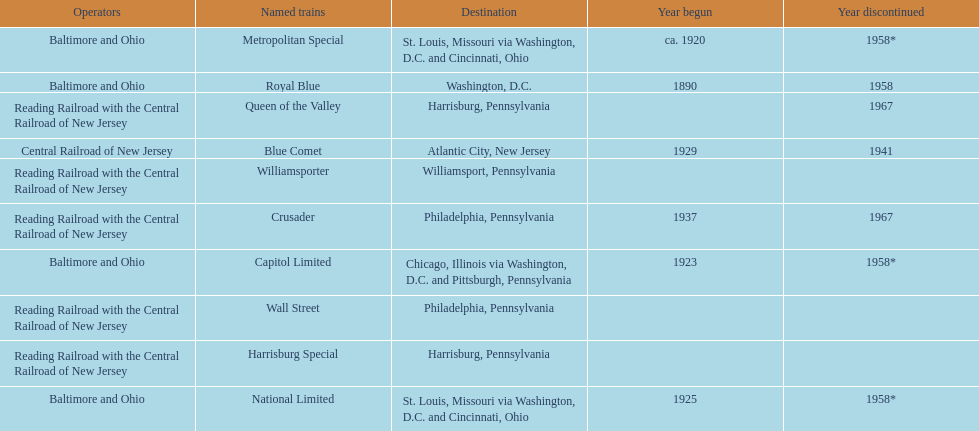Which other traine, other than wall street, had philadelphia as a destination? Crusader. Give me the full table as a dictionary. {'header': ['Operators', 'Named trains', 'Destination', 'Year begun', 'Year discontinued'], 'rows': [['Baltimore and Ohio', 'Metropolitan Special', 'St. Louis, Missouri via Washington, D.C. and Cincinnati, Ohio', 'ca. 1920', '1958*'], ['Baltimore and Ohio', 'Royal Blue', 'Washington, D.C.', '1890', '1958'], ['Reading Railroad with the Central Railroad of New Jersey', 'Queen of the Valley', 'Harrisburg, Pennsylvania', '', '1967'], ['Central Railroad of New Jersey', 'Blue Comet', 'Atlantic City, New Jersey', '1929', '1941'], ['Reading Railroad with the Central Railroad of New Jersey', 'Williamsporter', 'Williamsport, Pennsylvania', '', ''], ['Reading Railroad with the Central Railroad of New Jersey', 'Crusader', 'Philadelphia, Pennsylvania', '1937', '1967'], ['Baltimore and Ohio', 'Capitol Limited', 'Chicago, Illinois via Washington, D.C. and Pittsburgh, Pennsylvania', '1923', '1958*'], ['Reading Railroad with the Central Railroad of New Jersey', 'Wall Street', 'Philadelphia, Pennsylvania', '', ''], ['Reading Railroad with the Central Railroad of New Jersey', 'Harrisburg Special', 'Harrisburg, Pennsylvania', '', ''], ['Baltimore and Ohio', 'National Limited', 'St. Louis, Missouri via Washington, D.C. and Cincinnati, Ohio', '1925', '1958*']]} 